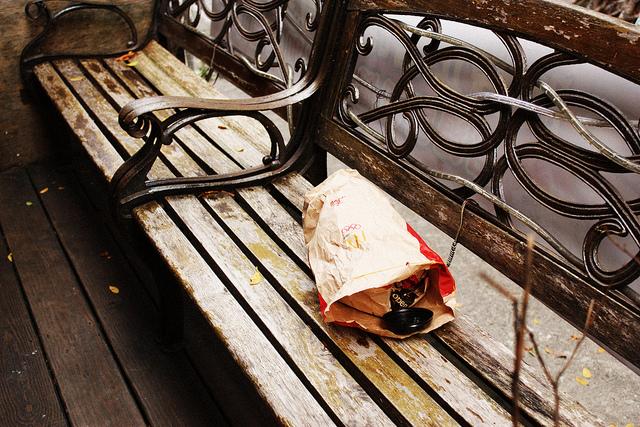How many boards make up the bench seat?
Answer briefly. 5. What is the bench seat made of?
Write a very short answer. Wood. What is inside of the bag?
Give a very brief answer. Trash. 